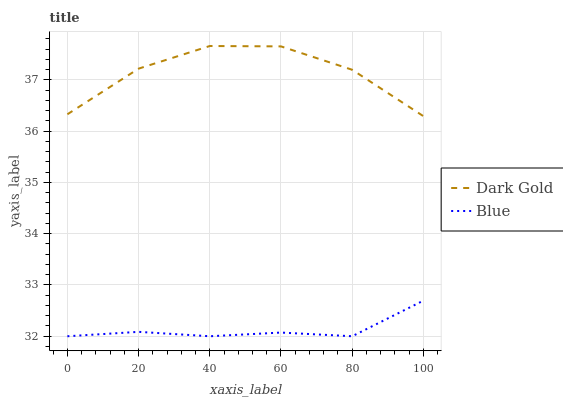Does Blue have the minimum area under the curve?
Answer yes or no. Yes. Does Dark Gold have the maximum area under the curve?
Answer yes or no. Yes. Does Dark Gold have the minimum area under the curve?
Answer yes or no. No. Is Blue the smoothest?
Answer yes or no. Yes. Is Dark Gold the roughest?
Answer yes or no. Yes. Is Dark Gold the smoothest?
Answer yes or no. No. Does Dark Gold have the lowest value?
Answer yes or no. No. Does Dark Gold have the highest value?
Answer yes or no. Yes. Is Blue less than Dark Gold?
Answer yes or no. Yes. Is Dark Gold greater than Blue?
Answer yes or no. Yes. Does Blue intersect Dark Gold?
Answer yes or no. No. 